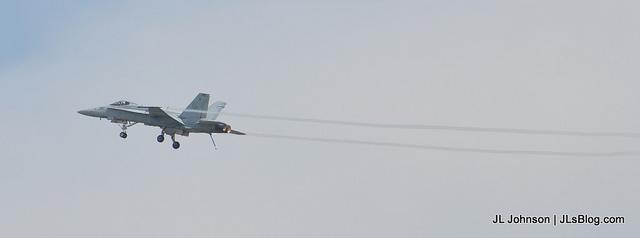What term is used to describe this kind of picture on the Internet?
Quick response, please. Plane. What type of aircraft is this?
Keep it brief. Jet. Who owns the picture?
Short answer required. Jl johnson. What's behind the jet?
Keep it brief. Smoke. Is the plane in the air?
Answer briefly. Yes. Is the landing gear down?
Be succinct. Yes. What is on the bottom of the plane?
Give a very brief answer. Wheels. 